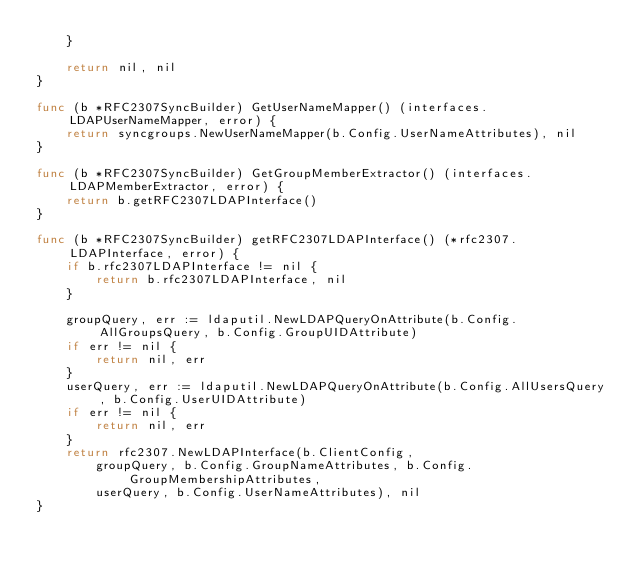<code> <loc_0><loc_0><loc_500><loc_500><_Go_>	}

	return nil, nil
}

func (b *RFC2307SyncBuilder) GetUserNameMapper() (interfaces.LDAPUserNameMapper, error) {
	return syncgroups.NewUserNameMapper(b.Config.UserNameAttributes), nil
}

func (b *RFC2307SyncBuilder) GetGroupMemberExtractor() (interfaces.LDAPMemberExtractor, error) {
	return b.getRFC2307LDAPInterface()
}

func (b *RFC2307SyncBuilder) getRFC2307LDAPInterface() (*rfc2307.LDAPInterface, error) {
	if b.rfc2307LDAPInterface != nil {
		return b.rfc2307LDAPInterface, nil
	}

	groupQuery, err := ldaputil.NewLDAPQueryOnAttribute(b.Config.AllGroupsQuery, b.Config.GroupUIDAttribute)
	if err != nil {
		return nil, err
	}
	userQuery, err := ldaputil.NewLDAPQueryOnAttribute(b.Config.AllUsersQuery, b.Config.UserUIDAttribute)
	if err != nil {
		return nil, err
	}
	return rfc2307.NewLDAPInterface(b.ClientConfig,
		groupQuery, b.Config.GroupNameAttributes, b.Config.GroupMembershipAttributes,
		userQuery, b.Config.UserNameAttributes), nil
}
</code> 